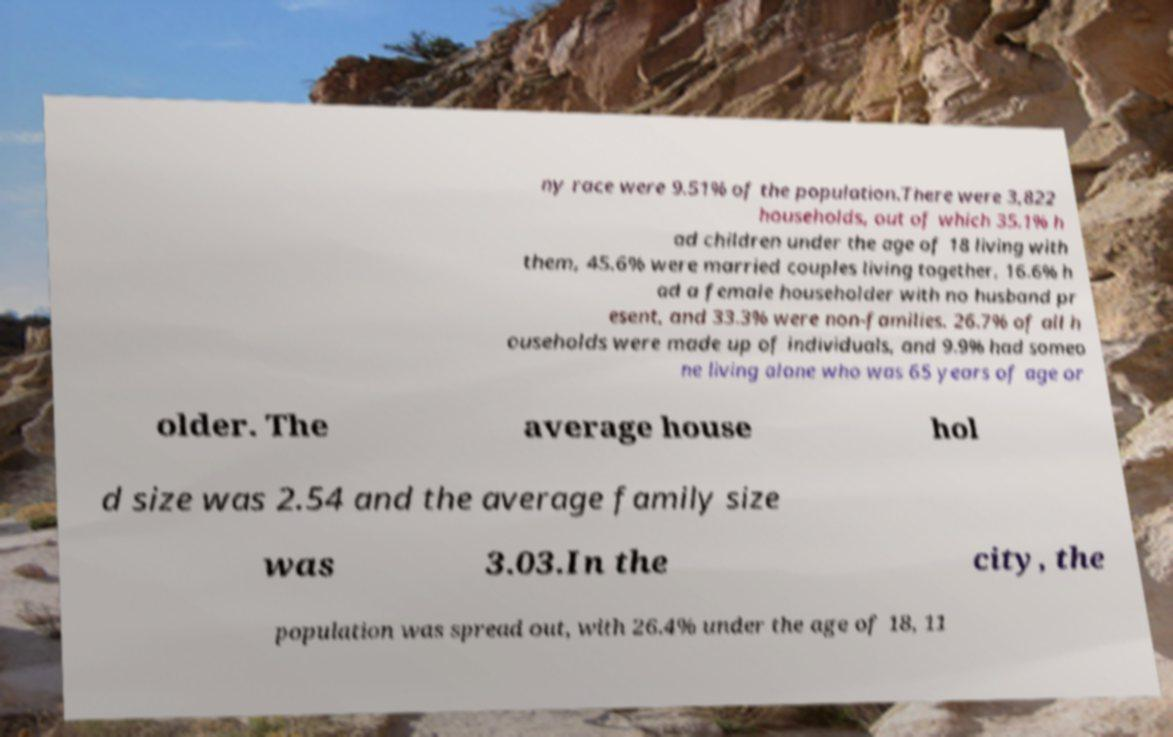Can you accurately transcribe the text from the provided image for me? ny race were 9.51% of the population.There were 3,822 households, out of which 35.1% h ad children under the age of 18 living with them, 45.6% were married couples living together, 16.6% h ad a female householder with no husband pr esent, and 33.3% were non-families. 26.7% of all h ouseholds were made up of individuals, and 9.9% had someo ne living alone who was 65 years of age or older. The average house hol d size was 2.54 and the average family size was 3.03.In the city, the population was spread out, with 26.4% under the age of 18, 11 